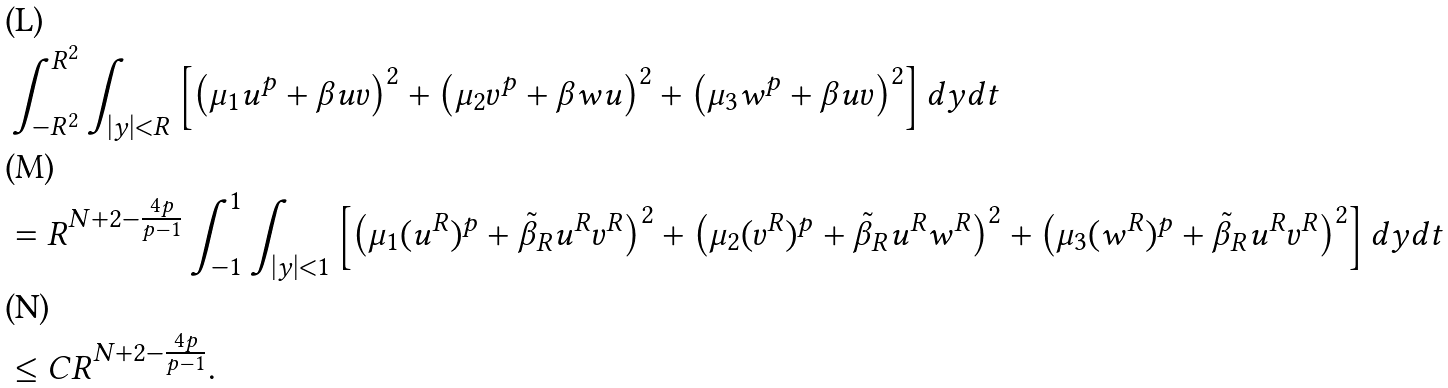<formula> <loc_0><loc_0><loc_500><loc_500>& \int _ { - R ^ { 2 } } ^ { R ^ { 2 } } \int _ { | y | < R } \left [ \left ( \mu _ { 1 } u ^ { p } + \beta u v \right ) ^ { 2 } + \left ( \mu _ { 2 } v ^ { p } + \beta w u \right ) ^ { 2 } + \left ( \mu _ { 3 } w ^ { p } + \beta u v \right ) ^ { 2 } \right ] d y d t \\ & = R ^ { N + 2 - \frac { 4 p } { p - 1 } } \int _ { - 1 } ^ { 1 } \int _ { | y | < 1 } \left [ \left ( \mu _ { 1 } ( u ^ { R } ) ^ { p } + \tilde { \beta } _ { R } u ^ { R } v ^ { R } \right ) ^ { 2 } + \left ( \mu _ { 2 } ( v ^ { R } ) ^ { p } + \tilde { \beta } _ { R } u ^ { R } w ^ { R } \right ) ^ { 2 } + \left ( \mu _ { 3 } ( w ^ { R } ) ^ { p } + \tilde { \beta } _ { R } u ^ { R } v ^ { R } \right ) ^ { 2 } \right ] d y d t \\ & \leq C R ^ { N + 2 - \frac { 4 p } { p - 1 } } .</formula> 